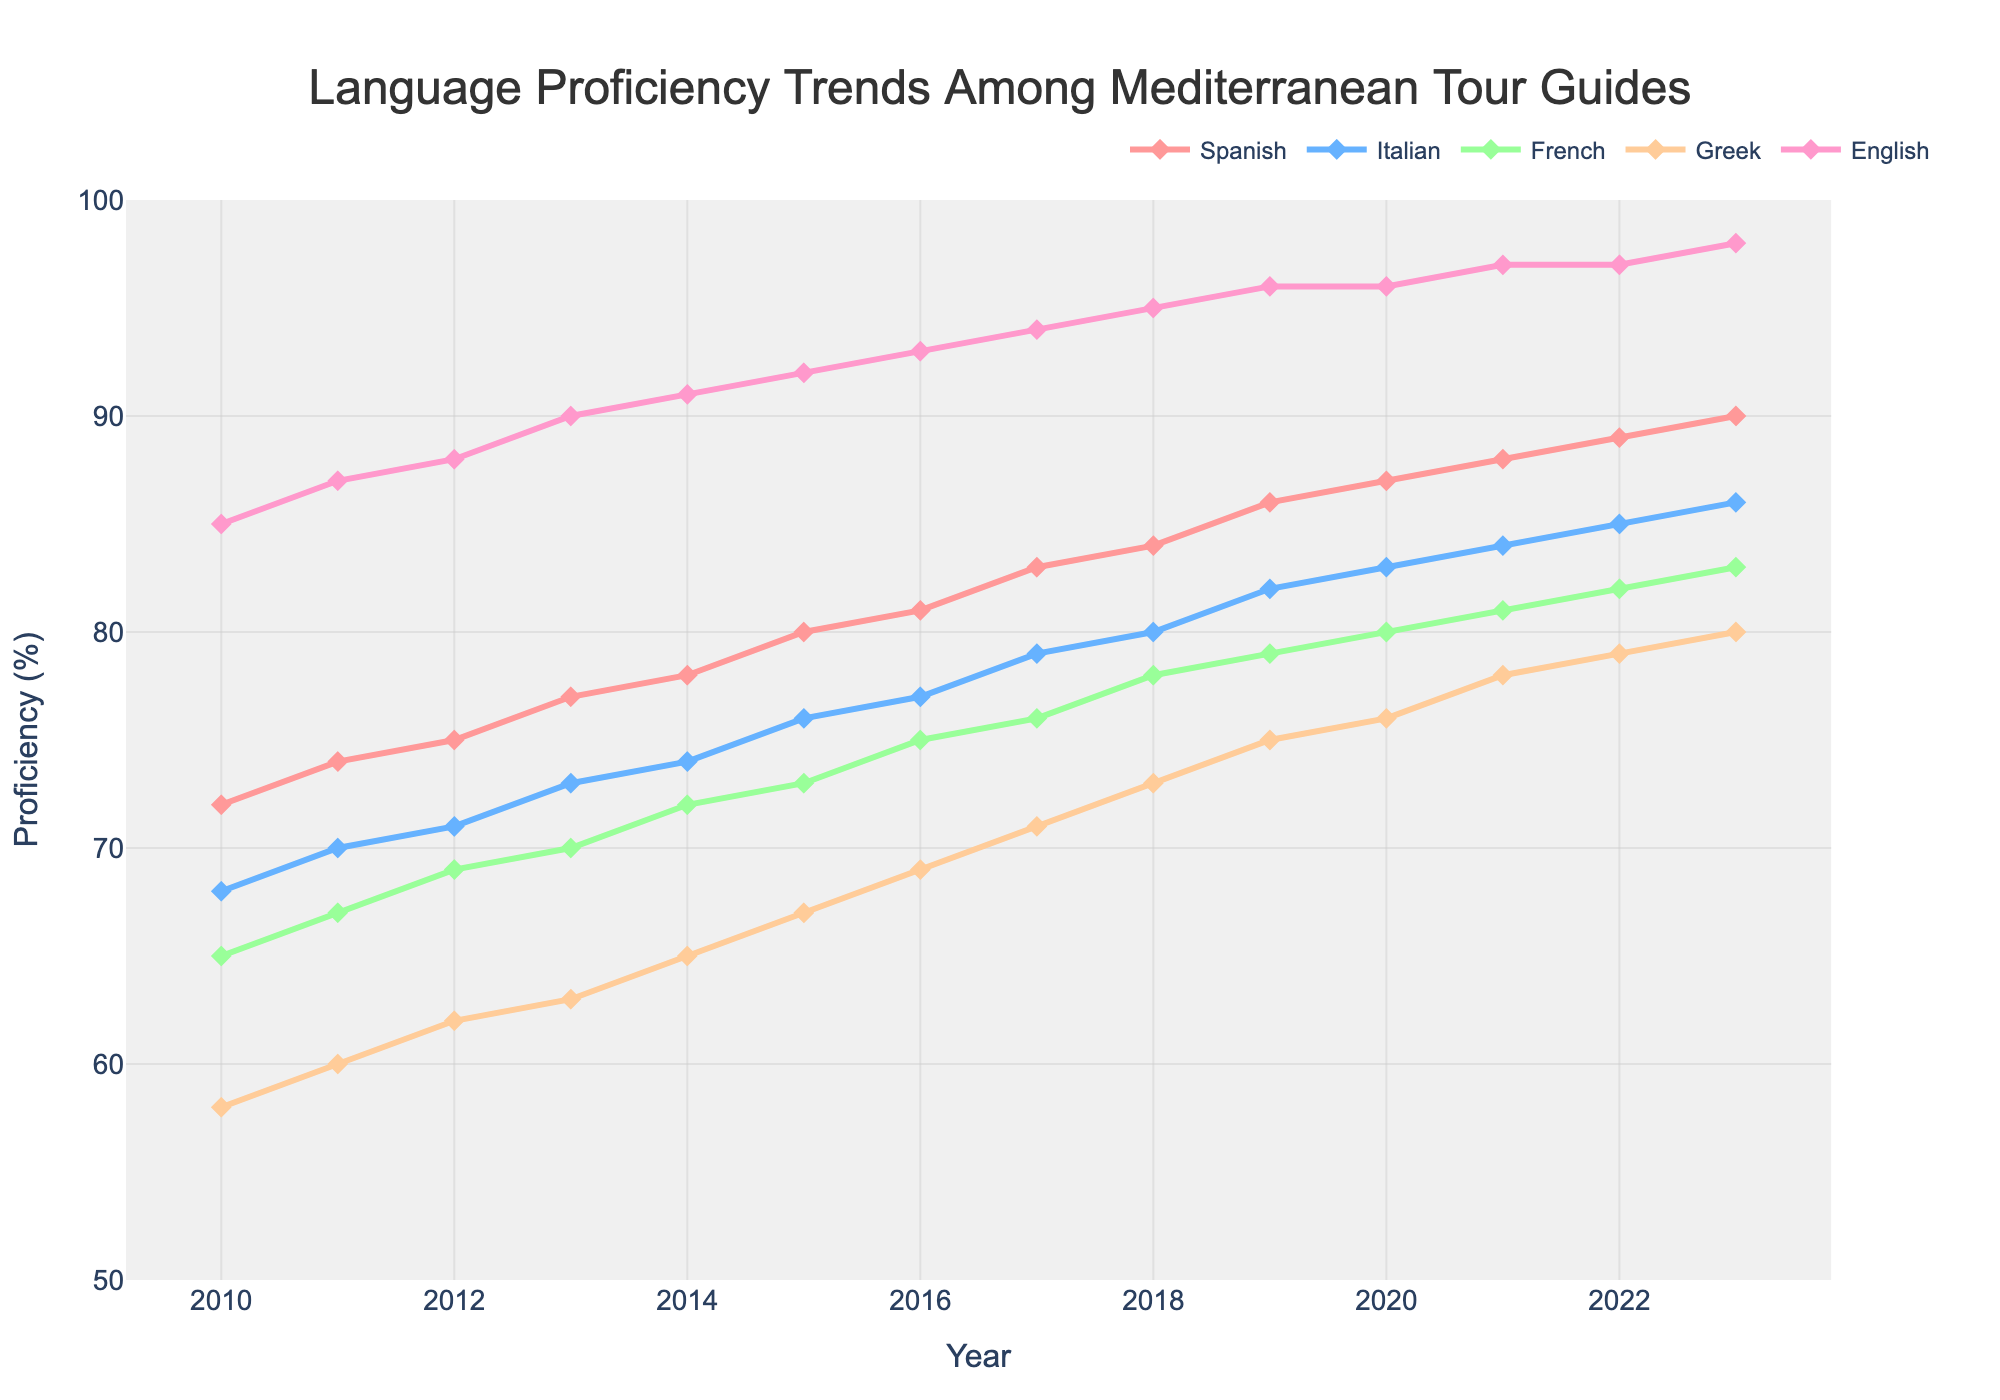Which year shows the highest proficiency in English among Mediterranean tour guides? English proficiency peaks at 98% in 2023 according to the graph.
Answer: 2023 Which language had a higher proficiency increase from 2010 to 2023, Italian or Greek? Italian proficiency increased from 68% to 86%, resulting in an 18% rise. Greek proficiency, meanwhile, went from 58% to 80%, a 22% increase, making Greek's proficiency rise higher.
Answer: Greek Between 2015 and 2020, which language saw the least overall improvement in proficiency? Between 2015 and 2020, Greek proficiency increased from 67% to 76%, showing a 9% rise. French proficiency increased from 73% to 80%, showing a 7% rise. Both Italian and English improved by 7%. Spanish improved the most with a rise of 7%, hence French saw the least improvement.
Answer: French What was the average proficiency in Spanish for the years 2010 to 2023? Adding up the Spanish proficiency percentages from 2010 to 2023 sums to 1164. Dividing by the 14 years, the average proficiency is 83.14%.
Answer: 83.14% How does the proficiency in English in 2013 compare to the proficiency in Greek in 2023? In 2013, English proficiency is at 90%. For Greek, proficiency in 2023 is at 80%. English in 2013 is 10% higher than Greek in 2023.
Answer: English in 2013 is higher Which language had the most consistent year-over-year growth from 2010 to 2023? English shows a steady and consistent growth, rising from 85% in 2010 to 98% in 2023, with no drops in any year and increments each year.
Answer: English In 2017, how many languages had a proficiency over 75%? Checking the graph for 2017, Spanish stands at 83%, Italian at 79%, and English at 94%. French and Greek are both below 75% that year. Therefore, Spanish, Italian, and English have a proficiency above 75%. That makes three languages.
Answer: Three languages In which year does French proficiency first exceed 70%? According to the graph, French proficiency first exceeds 70% in 2014, where it reaches 72%.
Answer: 2014 